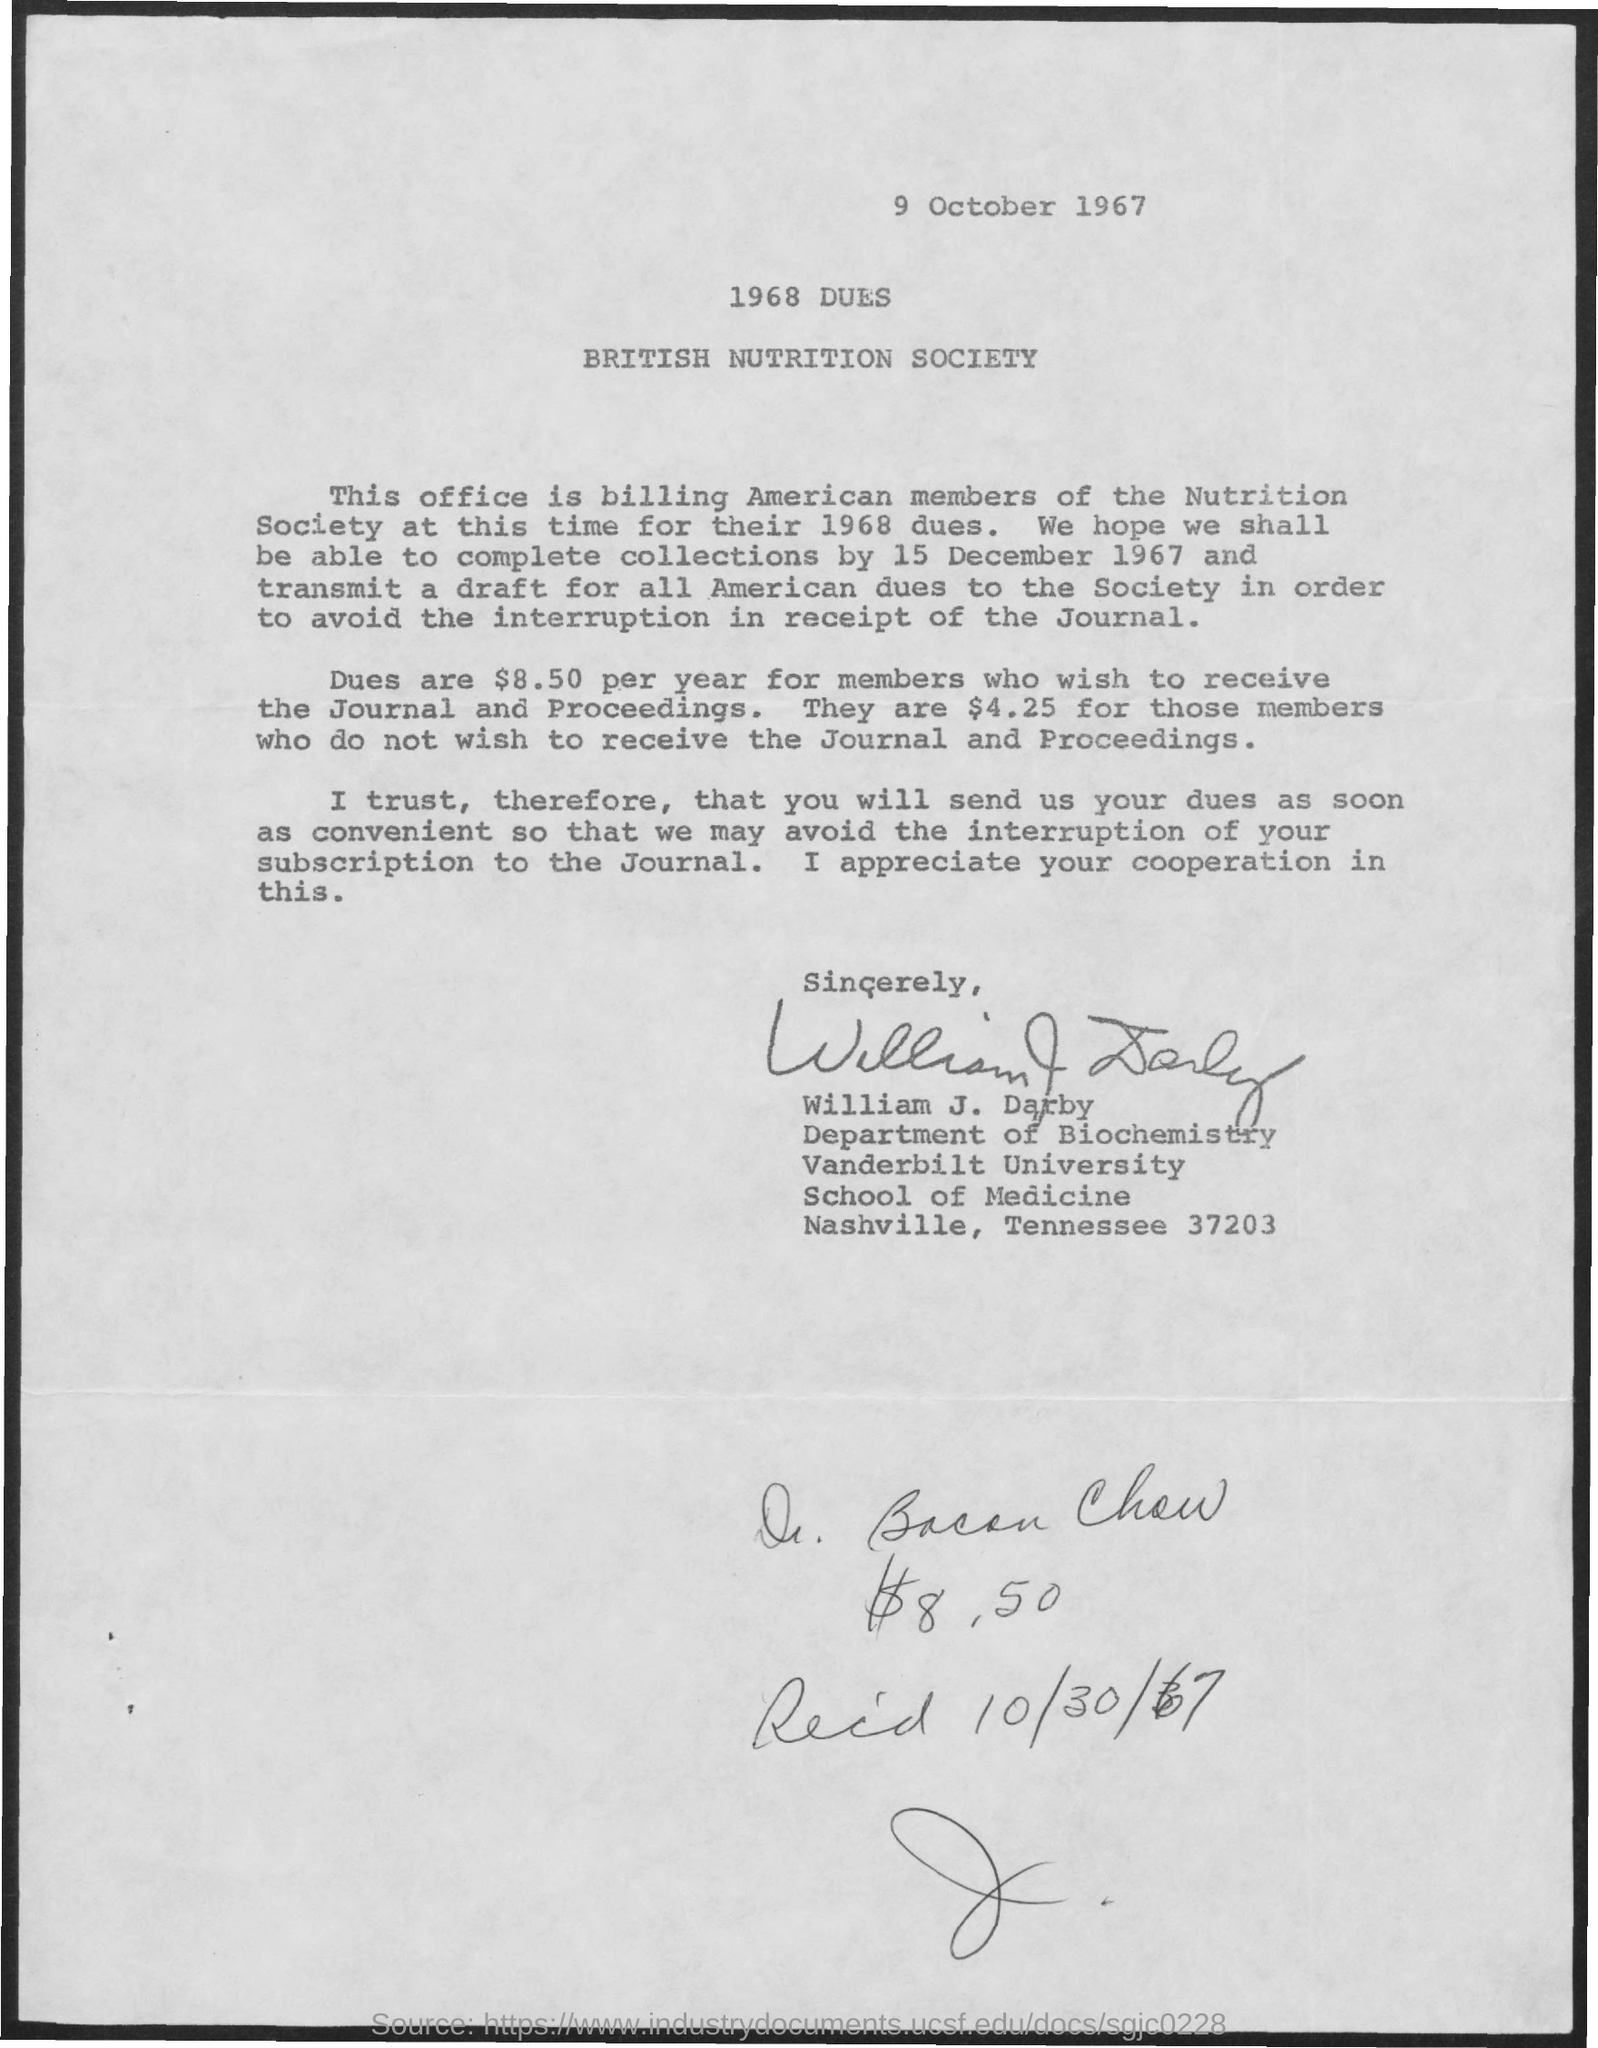Point out several critical features in this image. The date mentioned at the top of the document is 9 October 1967. 